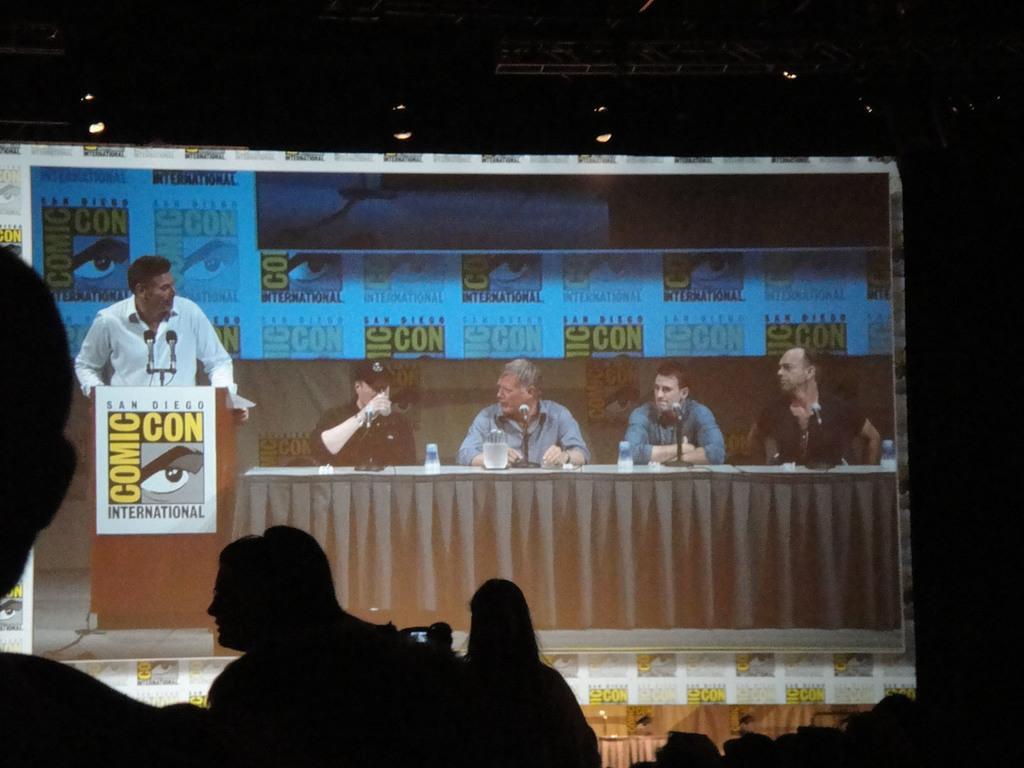In one or two sentences, can you explain what this image depicts? As we can see in the image there are few people here and there, table, banner, mic and few of them are sitting on chairs. On tables there are mice and glasses. 